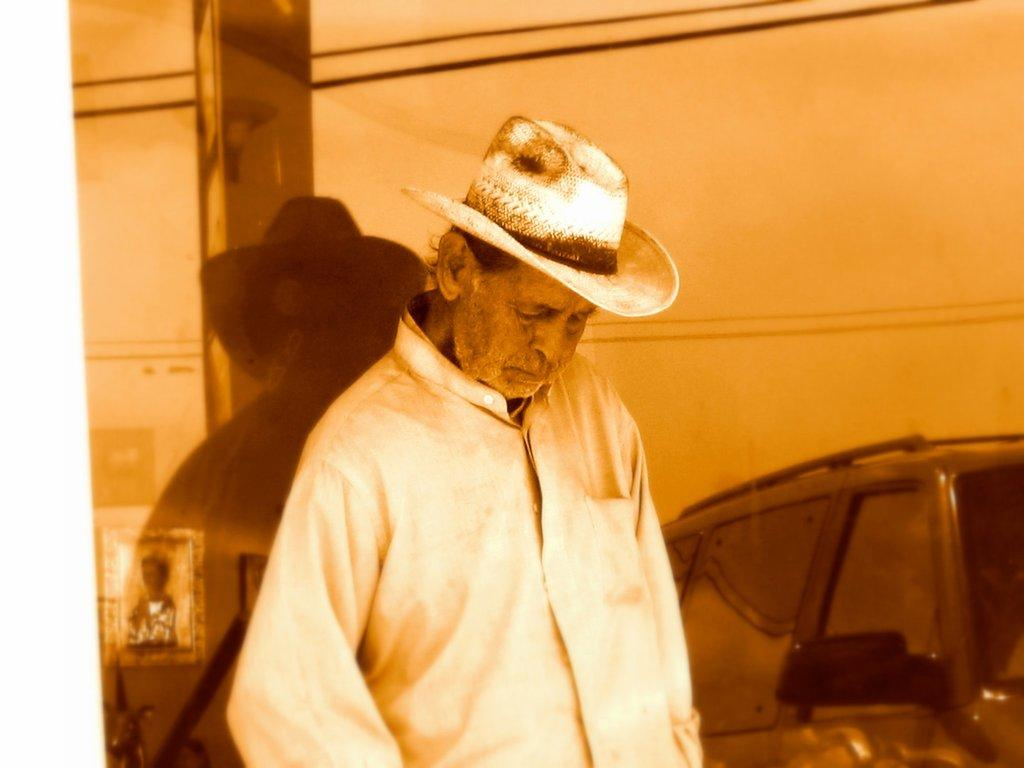Who is present in the image? There is a man in the image. What is the man wearing on his head? The man is wearing a hat. What can be seen behind the man? There is a car behind the man. What is on the left side of the image? There is a glass on the left side of the image. What is visible through the glass? Frames are visible through the glass. What type of farm can be seen in the image? There is no farm present in the image. 